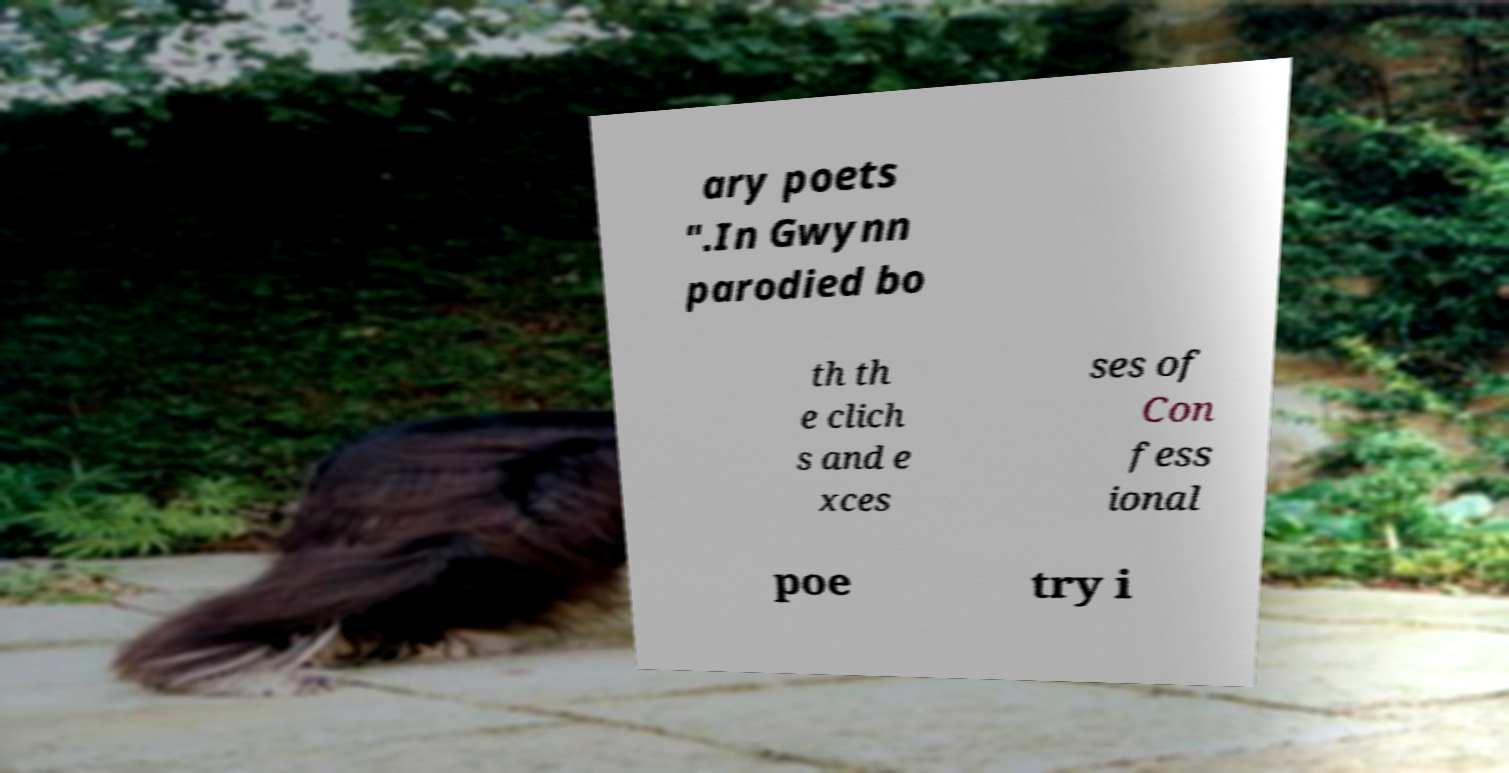Please identify and transcribe the text found in this image. ary poets ".In Gwynn parodied bo th th e clich s and e xces ses of Con fess ional poe try i 